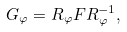Convert formula to latex. <formula><loc_0><loc_0><loc_500><loc_500>G _ { \varphi } = R _ { \varphi } F R _ { \varphi } ^ { - 1 } ,</formula> 